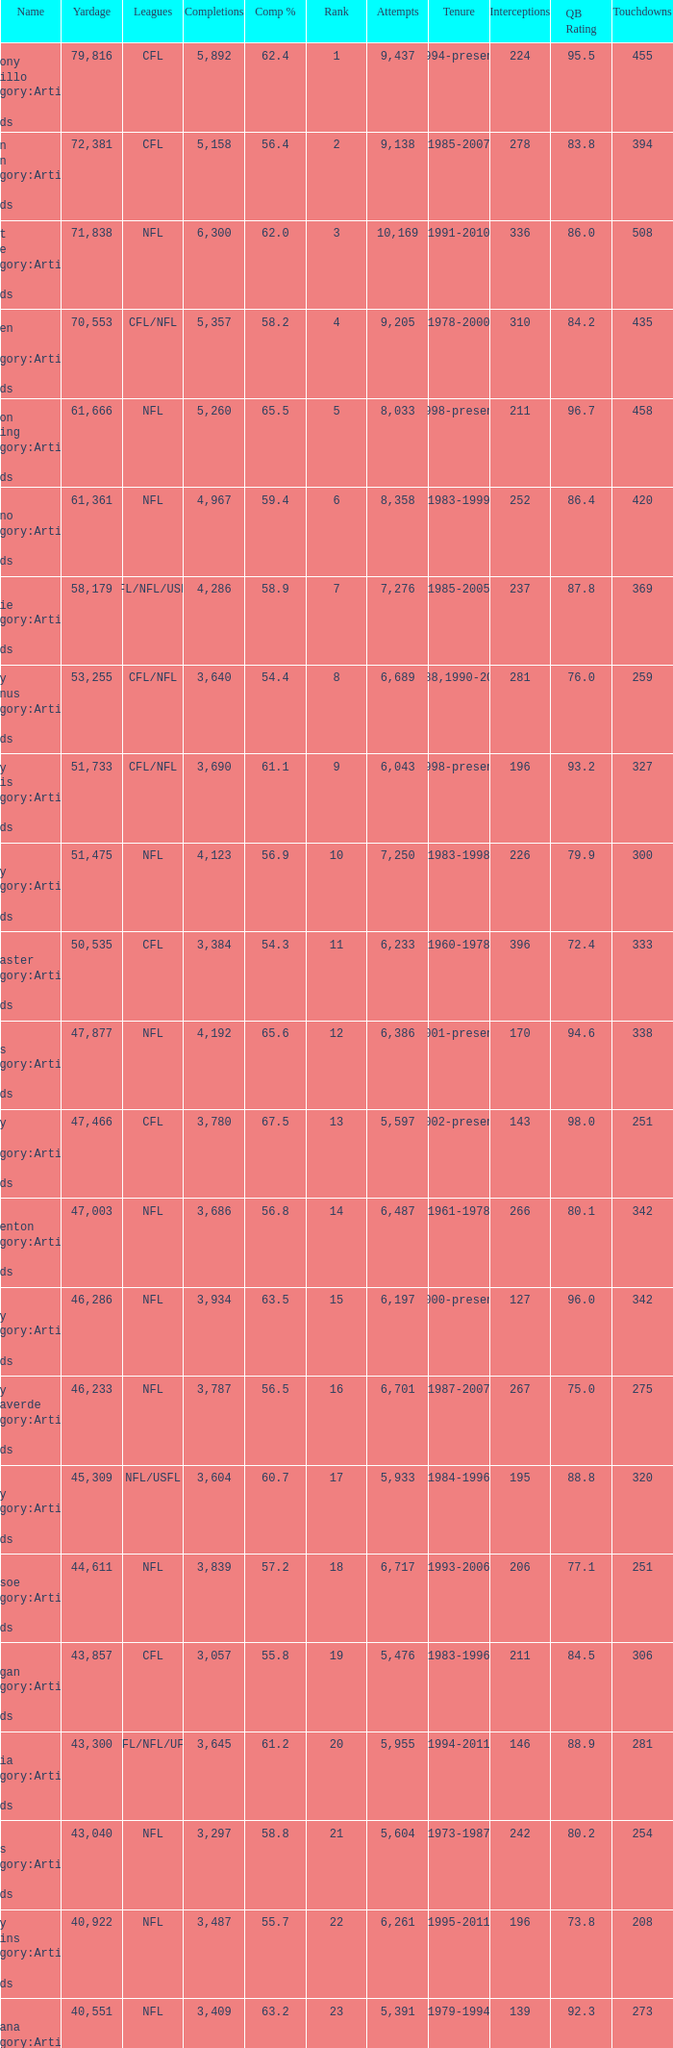Parse the full table. {'header': ['Name', 'Yardage', 'Leagues', 'Completions', 'Comp %', 'Rank', 'Attempts', 'Tenure', 'Interceptions', 'QB Rating', 'Touchdowns'], 'rows': [['Anthony Calvillo Category:Articles with hCards', '79,816', 'CFL', '5,892', '62.4', '1', '9,437', '1994-present', '224', '95.5', '455'], ['Damon Allen Category:Articles with hCards', '72,381', 'CFL', '5,158', '56.4', '2', '9,138', '1985-2007', '278', '83.8', '394'], ['Brett Favre Category:Articles with hCards', '71,838', 'NFL', '6,300', '62.0', '3', '10,169', '1991-2010', '336', '86.0', '508'], ['Warren Moon Category:Articles with hCards', '70,553', 'CFL/NFL', '5,357', '58.2', '4', '9,205', '1978-2000', '310', '84.2', '435'], ['Peyton Manning Category:Articles with hCards', '61,666', 'NFL', '5,260', '65.5', '5', '8,033', '1998-present', '211', '96.7', '458'], ['Dan Marino Category:Articles with hCards', '61,361', 'NFL', '4,967', '59.4', '6', '8,358', '1983-1999', '252', '86.4', '420'], ['Doug Flutie Category:Articles with hCards', '58,179', 'CFL/NFL/USFL', '4,286', '58.9', '7', '7,276', '1985-2005', '237', '87.8', '369'], ['Danny McManus Category:Articles with hCards', '53,255', 'CFL/NFL', '3,640', '54.4', '8', '6,689', '1988,1990-2006', '281', '76.0', '259'], ['Henry Burris Category:Articles with hCards', '51,733', 'CFL/NFL', '3,690', '61.1', '9', '6,043', '1998-present', '196', '93.2', '327'], ['John Elway Category:Articles with hCards', '51,475', 'NFL', '4,123', '56.9', '10', '7,250', '1983-1998', '226', '79.9', '300'], ['Ron Lancaster Category:Articles with hCards', '50,535', 'CFL', '3,384', '54.3', '11', '6,233', '1960-1978', '396', '72.4', '333'], ['Drew Brees Category:Articles with hCards', '47,877', 'NFL', '4,192', '65.6', '12', '6,386', '2001-present', '170', '94.6', '338'], ['Ricky Ray Category:Articles with hCards', '47,466', 'CFL', '3,780', '67.5', '13', '5,597', '2002-present', '143', '98.0', '251'], ['Fran Tarkenton Category:Articles with hCards', '47,003', 'NFL', '3,686', '56.8', '14', '6,487', '1961-1978', '266', '80.1', '342'], ['Tom Brady Category:Articles with hCards', '46,286', 'NFL', '3,934', '63.5', '15', '6,197', '2000-present', '127', '96.0', '342'], ['Vinny Testaverde Category:Articles with hCards', '46,233', 'NFL', '3,787', '56.5', '16', '6,701', '1987-2007', '267', '75.0', '275'], ['Jim Kelly Category:Articles with hCards', '45,309', 'NFL/USFL', '3,604', '60.7', '17', '5,933', '1984-1996', '195', '88.8', '320'], ['Drew Bledsoe Category:Articles with hCards', '44,611', 'NFL', '3,839', '57.2', '18', '6,717', '1993-2006', '206', '77.1', '251'], ['Matt Dunigan Category:Articles with hCards', '43,857', 'CFL', '3,057', '55.8', '19', '5,476', '1983-1996', '211', '84.5', '306'], ['Jeff Garcia Category:Articles with hCards', '43,300', 'CFL/NFL/UFL', '3,645', '61.2', '20', '5,955', '1994-2011', '146', '88.9', '281'], ['Dan Fouts Category:Articles with hCards', '43,040', 'NFL', '3,297', '58.8', '21', '5,604', '1973-1987', '242', '80.2', '254'], ['Kerry Collins Category:Articles with hCards', '40,922', 'NFL', '3,487', '55.7', '22', '6,261', '1995-2011', '196', '73.8', '208'], ['Joe Montana Category:Articles with hCards', '40,551', 'NFL', '3,409', '63.2', '23', '5,391', '1979-1994', '139', '92.3', '273'], ['Tracy Ham Category:Articles with hCards', '40,534', 'CFL', '2,670', '54.0', '24', '4,945', '1987-1999', '164', '86.6', '284'], ['Johnny Unitas Category:Articles with hCards', '40,239', 'NFL', '2,830', '54.6', '25', '5,186', '1956-1973', '253', '78.2', '290']]} What is the comp percentage when there are less than 44,611 in yardage, more than 254 touchdowns, and rank larger than 24? 54.6. 